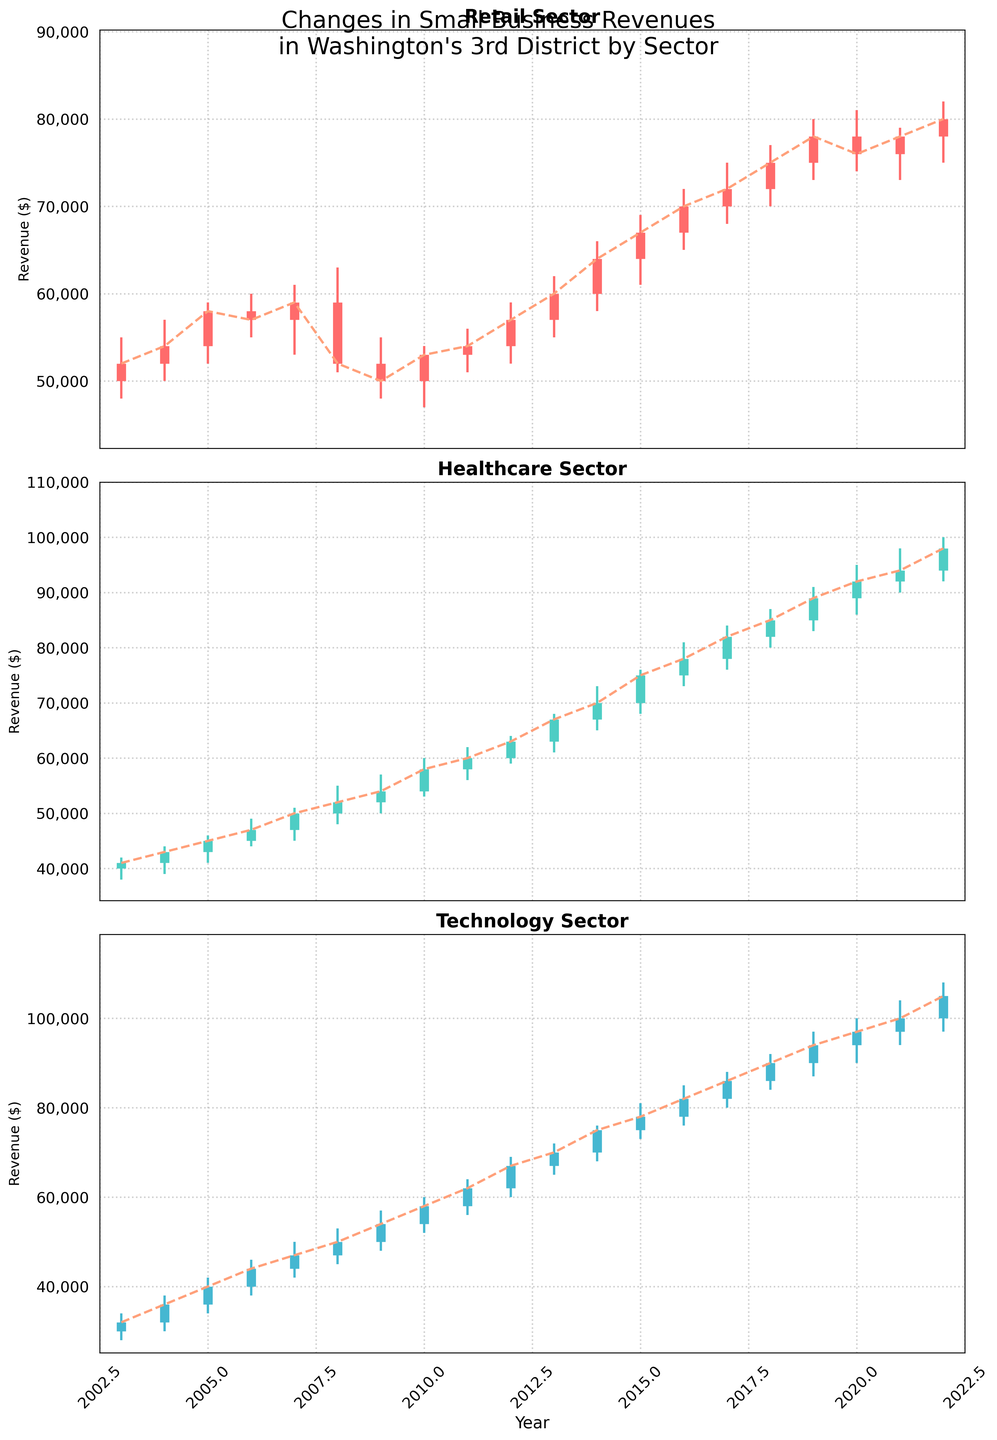What is the title of the plot? The title is located at the top of the plot, clearly stating the subject
Answer: Changes in Small Business Revenues in Washington's 3rd District by Sector Which sector had the highest closing revenue in 2022? The closing revenue for each sector in 2022 is represented at the endpoint of the candlestick. The Technology sector closes at the highest position
Answer: Technology How did the Retail sector closing revenue in 2020 compare to its opening revenue in 2020? For the Retail sector in 2020, compare the position of 'Open' (78000) at the bottom of the thick bar and 'Close' (76000) at the top; since 'Close' is lower than 'Open,' the revenue decreased
Answer: It decreased In which year did the Healthcare sector experience the highest volatility? Volatility is represented by the difference between the high and low points of the candlestick. The year with the longest vertical line representing the difference between high and low is 2021
Answer: 2021 What's the average closing revenue for the Retail sector over the last 20 years? Sum up the closing values for Retail from 2003 to 2022 and divide by the number of years (20). (52000+54000+58000+57000+59000+52000+50000+53000+54000+57000+60000+64000+67000+70000+72000+75000+78000+76000+78000+80000)/20=61850
Answer: 61850 Which sector showed a consistent upward trend in closing revenues? Check the trend lines; the Technology sector shows a consistent upward slope for closing revenues from 2003 to 2022
Answer: Technology How did the Healthcare sector revenue change from 2008 to 2009? Compare the 'Close' values for Healthcare in 2008 (52000) and 2009 (54000); from the lower bar for 2008 to the higher bar for 2009, revenue increased
Answer: It increased Between Retail and Technology sectors, which had a higher high value in 2015? Compare the high point (the upper end of the candlestick) for both sectors in 2015, Retail (69000) and Technology (81000); Technology is higher
Answer: Technology What is the general trend for the Retail sector's closing revenue from 2009 to 2014? Observe the position of the closing prices for Retail from 2009 (50000) to 2014 (64000); the general trend is an increasing slope
Answer: Increasing Which sector had both its lowest low and highest high in the same year? Compare candlesticks with the longest vertical span relative to other years for each sector; the Technology sector in 2022 had the highest high (108000) and the lowest low (97000)
Answer: Technology 